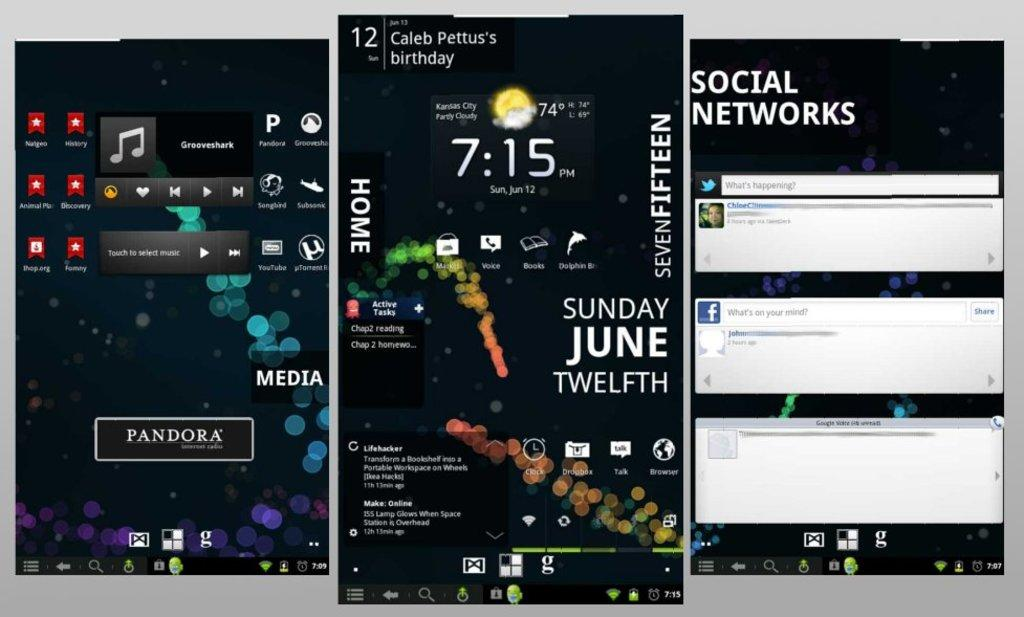<image>
Relay a brief, clear account of the picture shown. screenshots of a phone screen with the word 'pandora' on one of them 